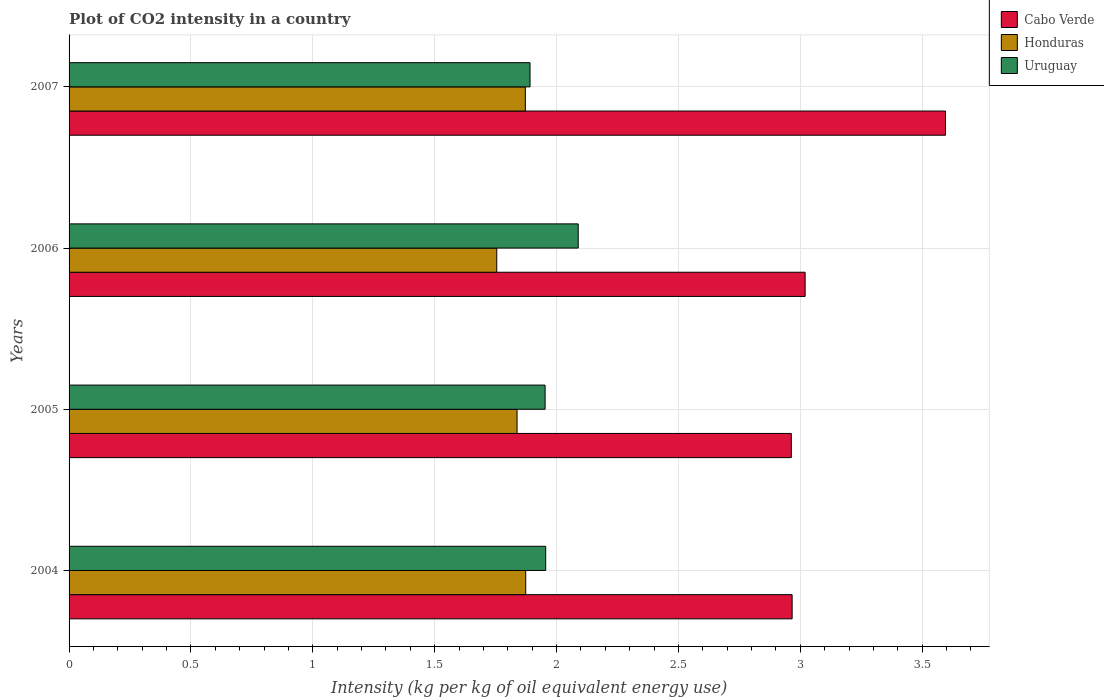Are the number of bars on each tick of the Y-axis equal?
Give a very brief answer. Yes. How many bars are there on the 3rd tick from the top?
Keep it short and to the point. 3. What is the label of the 3rd group of bars from the top?
Keep it short and to the point. 2005. In how many cases, is the number of bars for a given year not equal to the number of legend labels?
Your answer should be very brief. 0. What is the CO2 intensity in in Honduras in 2004?
Your answer should be compact. 1.87. Across all years, what is the maximum CO2 intensity in in Uruguay?
Your response must be concise. 2.09. Across all years, what is the minimum CO2 intensity in in Uruguay?
Your answer should be very brief. 1.89. In which year was the CO2 intensity in in Uruguay maximum?
Your answer should be compact. 2006. In which year was the CO2 intensity in in Cabo Verde minimum?
Your answer should be compact. 2005. What is the total CO2 intensity in in Honduras in the graph?
Provide a short and direct response. 7.34. What is the difference between the CO2 intensity in in Honduras in 2004 and that in 2005?
Your answer should be compact. 0.04. What is the difference between the CO2 intensity in in Cabo Verde in 2006 and the CO2 intensity in in Honduras in 2007?
Provide a succinct answer. 1.15. What is the average CO2 intensity in in Cabo Verde per year?
Your answer should be compact. 3.14. In the year 2005, what is the difference between the CO2 intensity in in Cabo Verde and CO2 intensity in in Uruguay?
Offer a very short reply. 1.01. In how many years, is the CO2 intensity in in Cabo Verde greater than 0.6 kg?
Offer a terse response. 4. What is the ratio of the CO2 intensity in in Honduras in 2004 to that in 2007?
Provide a short and direct response. 1. Is the CO2 intensity in in Honduras in 2004 less than that in 2006?
Offer a very short reply. No. Is the difference between the CO2 intensity in in Cabo Verde in 2004 and 2007 greater than the difference between the CO2 intensity in in Uruguay in 2004 and 2007?
Provide a short and direct response. No. What is the difference between the highest and the second highest CO2 intensity in in Honduras?
Make the answer very short. 0. What is the difference between the highest and the lowest CO2 intensity in in Honduras?
Ensure brevity in your answer.  0.12. What does the 3rd bar from the top in 2006 represents?
Your answer should be compact. Cabo Verde. What does the 1st bar from the bottom in 2007 represents?
Provide a short and direct response. Cabo Verde. Is it the case that in every year, the sum of the CO2 intensity in in Uruguay and CO2 intensity in in Cabo Verde is greater than the CO2 intensity in in Honduras?
Offer a very short reply. Yes. How many bars are there?
Provide a short and direct response. 12. Are all the bars in the graph horizontal?
Offer a very short reply. Yes. Are the values on the major ticks of X-axis written in scientific E-notation?
Give a very brief answer. No. Where does the legend appear in the graph?
Keep it short and to the point. Top right. How many legend labels are there?
Offer a terse response. 3. How are the legend labels stacked?
Your answer should be very brief. Vertical. What is the title of the graph?
Offer a very short reply. Plot of CO2 intensity in a country. What is the label or title of the X-axis?
Your answer should be very brief. Intensity (kg per kg of oil equivalent energy use). What is the Intensity (kg per kg of oil equivalent energy use) in Cabo Verde in 2004?
Your answer should be compact. 2.97. What is the Intensity (kg per kg of oil equivalent energy use) in Honduras in 2004?
Your answer should be compact. 1.87. What is the Intensity (kg per kg of oil equivalent energy use) in Uruguay in 2004?
Offer a terse response. 1.96. What is the Intensity (kg per kg of oil equivalent energy use) in Cabo Verde in 2005?
Offer a terse response. 2.96. What is the Intensity (kg per kg of oil equivalent energy use) of Honduras in 2005?
Your answer should be compact. 1.84. What is the Intensity (kg per kg of oil equivalent energy use) in Uruguay in 2005?
Your response must be concise. 1.95. What is the Intensity (kg per kg of oil equivalent energy use) in Cabo Verde in 2006?
Offer a very short reply. 3.02. What is the Intensity (kg per kg of oil equivalent energy use) in Honduras in 2006?
Offer a terse response. 1.75. What is the Intensity (kg per kg of oil equivalent energy use) of Uruguay in 2006?
Make the answer very short. 2.09. What is the Intensity (kg per kg of oil equivalent energy use) of Cabo Verde in 2007?
Offer a terse response. 3.6. What is the Intensity (kg per kg of oil equivalent energy use) of Honduras in 2007?
Your response must be concise. 1.87. What is the Intensity (kg per kg of oil equivalent energy use) of Uruguay in 2007?
Your response must be concise. 1.89. Across all years, what is the maximum Intensity (kg per kg of oil equivalent energy use) of Cabo Verde?
Make the answer very short. 3.6. Across all years, what is the maximum Intensity (kg per kg of oil equivalent energy use) of Honduras?
Provide a short and direct response. 1.87. Across all years, what is the maximum Intensity (kg per kg of oil equivalent energy use) of Uruguay?
Provide a short and direct response. 2.09. Across all years, what is the minimum Intensity (kg per kg of oil equivalent energy use) of Cabo Verde?
Provide a succinct answer. 2.96. Across all years, what is the minimum Intensity (kg per kg of oil equivalent energy use) of Honduras?
Provide a succinct answer. 1.75. Across all years, what is the minimum Intensity (kg per kg of oil equivalent energy use) in Uruguay?
Ensure brevity in your answer.  1.89. What is the total Intensity (kg per kg of oil equivalent energy use) in Cabo Verde in the graph?
Your answer should be very brief. 12.55. What is the total Intensity (kg per kg of oil equivalent energy use) in Honduras in the graph?
Offer a terse response. 7.34. What is the total Intensity (kg per kg of oil equivalent energy use) in Uruguay in the graph?
Provide a succinct answer. 7.89. What is the difference between the Intensity (kg per kg of oil equivalent energy use) of Cabo Verde in 2004 and that in 2005?
Provide a succinct answer. 0. What is the difference between the Intensity (kg per kg of oil equivalent energy use) in Honduras in 2004 and that in 2005?
Ensure brevity in your answer.  0.04. What is the difference between the Intensity (kg per kg of oil equivalent energy use) in Uruguay in 2004 and that in 2005?
Ensure brevity in your answer.  0. What is the difference between the Intensity (kg per kg of oil equivalent energy use) in Cabo Verde in 2004 and that in 2006?
Offer a very short reply. -0.05. What is the difference between the Intensity (kg per kg of oil equivalent energy use) of Honduras in 2004 and that in 2006?
Your answer should be very brief. 0.12. What is the difference between the Intensity (kg per kg of oil equivalent energy use) in Uruguay in 2004 and that in 2006?
Ensure brevity in your answer.  -0.13. What is the difference between the Intensity (kg per kg of oil equivalent energy use) of Cabo Verde in 2004 and that in 2007?
Make the answer very short. -0.63. What is the difference between the Intensity (kg per kg of oil equivalent energy use) of Honduras in 2004 and that in 2007?
Offer a very short reply. 0. What is the difference between the Intensity (kg per kg of oil equivalent energy use) of Uruguay in 2004 and that in 2007?
Offer a very short reply. 0.06. What is the difference between the Intensity (kg per kg of oil equivalent energy use) in Cabo Verde in 2005 and that in 2006?
Make the answer very short. -0.06. What is the difference between the Intensity (kg per kg of oil equivalent energy use) of Honduras in 2005 and that in 2006?
Give a very brief answer. 0.08. What is the difference between the Intensity (kg per kg of oil equivalent energy use) of Uruguay in 2005 and that in 2006?
Give a very brief answer. -0.14. What is the difference between the Intensity (kg per kg of oil equivalent energy use) in Cabo Verde in 2005 and that in 2007?
Ensure brevity in your answer.  -0.63. What is the difference between the Intensity (kg per kg of oil equivalent energy use) in Honduras in 2005 and that in 2007?
Keep it short and to the point. -0.03. What is the difference between the Intensity (kg per kg of oil equivalent energy use) of Uruguay in 2005 and that in 2007?
Your answer should be very brief. 0.06. What is the difference between the Intensity (kg per kg of oil equivalent energy use) in Cabo Verde in 2006 and that in 2007?
Ensure brevity in your answer.  -0.58. What is the difference between the Intensity (kg per kg of oil equivalent energy use) in Honduras in 2006 and that in 2007?
Your answer should be very brief. -0.12. What is the difference between the Intensity (kg per kg of oil equivalent energy use) in Uruguay in 2006 and that in 2007?
Keep it short and to the point. 0.2. What is the difference between the Intensity (kg per kg of oil equivalent energy use) of Cabo Verde in 2004 and the Intensity (kg per kg of oil equivalent energy use) of Honduras in 2005?
Ensure brevity in your answer.  1.13. What is the difference between the Intensity (kg per kg of oil equivalent energy use) of Cabo Verde in 2004 and the Intensity (kg per kg of oil equivalent energy use) of Uruguay in 2005?
Offer a terse response. 1.01. What is the difference between the Intensity (kg per kg of oil equivalent energy use) of Honduras in 2004 and the Intensity (kg per kg of oil equivalent energy use) of Uruguay in 2005?
Your response must be concise. -0.08. What is the difference between the Intensity (kg per kg of oil equivalent energy use) of Cabo Verde in 2004 and the Intensity (kg per kg of oil equivalent energy use) of Honduras in 2006?
Offer a very short reply. 1.21. What is the difference between the Intensity (kg per kg of oil equivalent energy use) of Cabo Verde in 2004 and the Intensity (kg per kg of oil equivalent energy use) of Uruguay in 2006?
Offer a terse response. 0.88. What is the difference between the Intensity (kg per kg of oil equivalent energy use) of Honduras in 2004 and the Intensity (kg per kg of oil equivalent energy use) of Uruguay in 2006?
Your response must be concise. -0.22. What is the difference between the Intensity (kg per kg of oil equivalent energy use) in Cabo Verde in 2004 and the Intensity (kg per kg of oil equivalent energy use) in Honduras in 2007?
Ensure brevity in your answer.  1.09. What is the difference between the Intensity (kg per kg of oil equivalent energy use) in Cabo Verde in 2004 and the Intensity (kg per kg of oil equivalent energy use) in Uruguay in 2007?
Ensure brevity in your answer.  1.08. What is the difference between the Intensity (kg per kg of oil equivalent energy use) in Honduras in 2004 and the Intensity (kg per kg of oil equivalent energy use) in Uruguay in 2007?
Offer a very short reply. -0.02. What is the difference between the Intensity (kg per kg of oil equivalent energy use) of Cabo Verde in 2005 and the Intensity (kg per kg of oil equivalent energy use) of Honduras in 2006?
Keep it short and to the point. 1.21. What is the difference between the Intensity (kg per kg of oil equivalent energy use) in Cabo Verde in 2005 and the Intensity (kg per kg of oil equivalent energy use) in Uruguay in 2006?
Provide a succinct answer. 0.87. What is the difference between the Intensity (kg per kg of oil equivalent energy use) in Honduras in 2005 and the Intensity (kg per kg of oil equivalent energy use) in Uruguay in 2006?
Offer a terse response. -0.25. What is the difference between the Intensity (kg per kg of oil equivalent energy use) in Cabo Verde in 2005 and the Intensity (kg per kg of oil equivalent energy use) in Honduras in 2007?
Offer a terse response. 1.09. What is the difference between the Intensity (kg per kg of oil equivalent energy use) of Cabo Verde in 2005 and the Intensity (kg per kg of oil equivalent energy use) of Uruguay in 2007?
Offer a terse response. 1.07. What is the difference between the Intensity (kg per kg of oil equivalent energy use) in Honduras in 2005 and the Intensity (kg per kg of oil equivalent energy use) in Uruguay in 2007?
Offer a terse response. -0.05. What is the difference between the Intensity (kg per kg of oil equivalent energy use) in Cabo Verde in 2006 and the Intensity (kg per kg of oil equivalent energy use) in Honduras in 2007?
Ensure brevity in your answer.  1.15. What is the difference between the Intensity (kg per kg of oil equivalent energy use) of Cabo Verde in 2006 and the Intensity (kg per kg of oil equivalent energy use) of Uruguay in 2007?
Your response must be concise. 1.13. What is the difference between the Intensity (kg per kg of oil equivalent energy use) in Honduras in 2006 and the Intensity (kg per kg of oil equivalent energy use) in Uruguay in 2007?
Provide a succinct answer. -0.14. What is the average Intensity (kg per kg of oil equivalent energy use) in Cabo Verde per year?
Keep it short and to the point. 3.14. What is the average Intensity (kg per kg of oil equivalent energy use) in Honduras per year?
Offer a terse response. 1.83. What is the average Intensity (kg per kg of oil equivalent energy use) in Uruguay per year?
Your answer should be compact. 1.97. In the year 2004, what is the difference between the Intensity (kg per kg of oil equivalent energy use) of Cabo Verde and Intensity (kg per kg of oil equivalent energy use) of Honduras?
Your answer should be very brief. 1.09. In the year 2004, what is the difference between the Intensity (kg per kg of oil equivalent energy use) of Cabo Verde and Intensity (kg per kg of oil equivalent energy use) of Uruguay?
Make the answer very short. 1.01. In the year 2004, what is the difference between the Intensity (kg per kg of oil equivalent energy use) in Honduras and Intensity (kg per kg of oil equivalent energy use) in Uruguay?
Make the answer very short. -0.08. In the year 2005, what is the difference between the Intensity (kg per kg of oil equivalent energy use) of Cabo Verde and Intensity (kg per kg of oil equivalent energy use) of Honduras?
Your answer should be compact. 1.13. In the year 2005, what is the difference between the Intensity (kg per kg of oil equivalent energy use) of Cabo Verde and Intensity (kg per kg of oil equivalent energy use) of Uruguay?
Keep it short and to the point. 1.01. In the year 2005, what is the difference between the Intensity (kg per kg of oil equivalent energy use) of Honduras and Intensity (kg per kg of oil equivalent energy use) of Uruguay?
Ensure brevity in your answer.  -0.12. In the year 2006, what is the difference between the Intensity (kg per kg of oil equivalent energy use) in Cabo Verde and Intensity (kg per kg of oil equivalent energy use) in Honduras?
Keep it short and to the point. 1.27. In the year 2006, what is the difference between the Intensity (kg per kg of oil equivalent energy use) of Honduras and Intensity (kg per kg of oil equivalent energy use) of Uruguay?
Your answer should be very brief. -0.33. In the year 2007, what is the difference between the Intensity (kg per kg of oil equivalent energy use) of Cabo Verde and Intensity (kg per kg of oil equivalent energy use) of Honduras?
Ensure brevity in your answer.  1.72. In the year 2007, what is the difference between the Intensity (kg per kg of oil equivalent energy use) of Cabo Verde and Intensity (kg per kg of oil equivalent energy use) of Uruguay?
Give a very brief answer. 1.7. In the year 2007, what is the difference between the Intensity (kg per kg of oil equivalent energy use) of Honduras and Intensity (kg per kg of oil equivalent energy use) of Uruguay?
Keep it short and to the point. -0.02. What is the ratio of the Intensity (kg per kg of oil equivalent energy use) in Cabo Verde in 2004 to that in 2005?
Your answer should be very brief. 1. What is the ratio of the Intensity (kg per kg of oil equivalent energy use) of Honduras in 2004 to that in 2005?
Provide a short and direct response. 1.02. What is the ratio of the Intensity (kg per kg of oil equivalent energy use) of Cabo Verde in 2004 to that in 2006?
Ensure brevity in your answer.  0.98. What is the ratio of the Intensity (kg per kg of oil equivalent energy use) in Honduras in 2004 to that in 2006?
Ensure brevity in your answer.  1.07. What is the ratio of the Intensity (kg per kg of oil equivalent energy use) in Uruguay in 2004 to that in 2006?
Offer a very short reply. 0.94. What is the ratio of the Intensity (kg per kg of oil equivalent energy use) of Cabo Verde in 2004 to that in 2007?
Ensure brevity in your answer.  0.82. What is the ratio of the Intensity (kg per kg of oil equivalent energy use) in Honduras in 2004 to that in 2007?
Your answer should be very brief. 1. What is the ratio of the Intensity (kg per kg of oil equivalent energy use) of Uruguay in 2004 to that in 2007?
Offer a very short reply. 1.03. What is the ratio of the Intensity (kg per kg of oil equivalent energy use) of Cabo Verde in 2005 to that in 2006?
Provide a short and direct response. 0.98. What is the ratio of the Intensity (kg per kg of oil equivalent energy use) of Honduras in 2005 to that in 2006?
Your response must be concise. 1.05. What is the ratio of the Intensity (kg per kg of oil equivalent energy use) in Uruguay in 2005 to that in 2006?
Your answer should be compact. 0.94. What is the ratio of the Intensity (kg per kg of oil equivalent energy use) in Cabo Verde in 2005 to that in 2007?
Offer a terse response. 0.82. What is the ratio of the Intensity (kg per kg of oil equivalent energy use) in Honduras in 2005 to that in 2007?
Provide a succinct answer. 0.98. What is the ratio of the Intensity (kg per kg of oil equivalent energy use) in Uruguay in 2005 to that in 2007?
Offer a terse response. 1.03. What is the ratio of the Intensity (kg per kg of oil equivalent energy use) of Cabo Verde in 2006 to that in 2007?
Give a very brief answer. 0.84. What is the ratio of the Intensity (kg per kg of oil equivalent energy use) in Honduras in 2006 to that in 2007?
Offer a very short reply. 0.94. What is the ratio of the Intensity (kg per kg of oil equivalent energy use) in Uruguay in 2006 to that in 2007?
Give a very brief answer. 1.1. What is the difference between the highest and the second highest Intensity (kg per kg of oil equivalent energy use) of Cabo Verde?
Provide a short and direct response. 0.58. What is the difference between the highest and the second highest Intensity (kg per kg of oil equivalent energy use) in Honduras?
Keep it short and to the point. 0. What is the difference between the highest and the second highest Intensity (kg per kg of oil equivalent energy use) in Uruguay?
Make the answer very short. 0.13. What is the difference between the highest and the lowest Intensity (kg per kg of oil equivalent energy use) in Cabo Verde?
Offer a terse response. 0.63. What is the difference between the highest and the lowest Intensity (kg per kg of oil equivalent energy use) in Honduras?
Provide a succinct answer. 0.12. What is the difference between the highest and the lowest Intensity (kg per kg of oil equivalent energy use) in Uruguay?
Give a very brief answer. 0.2. 